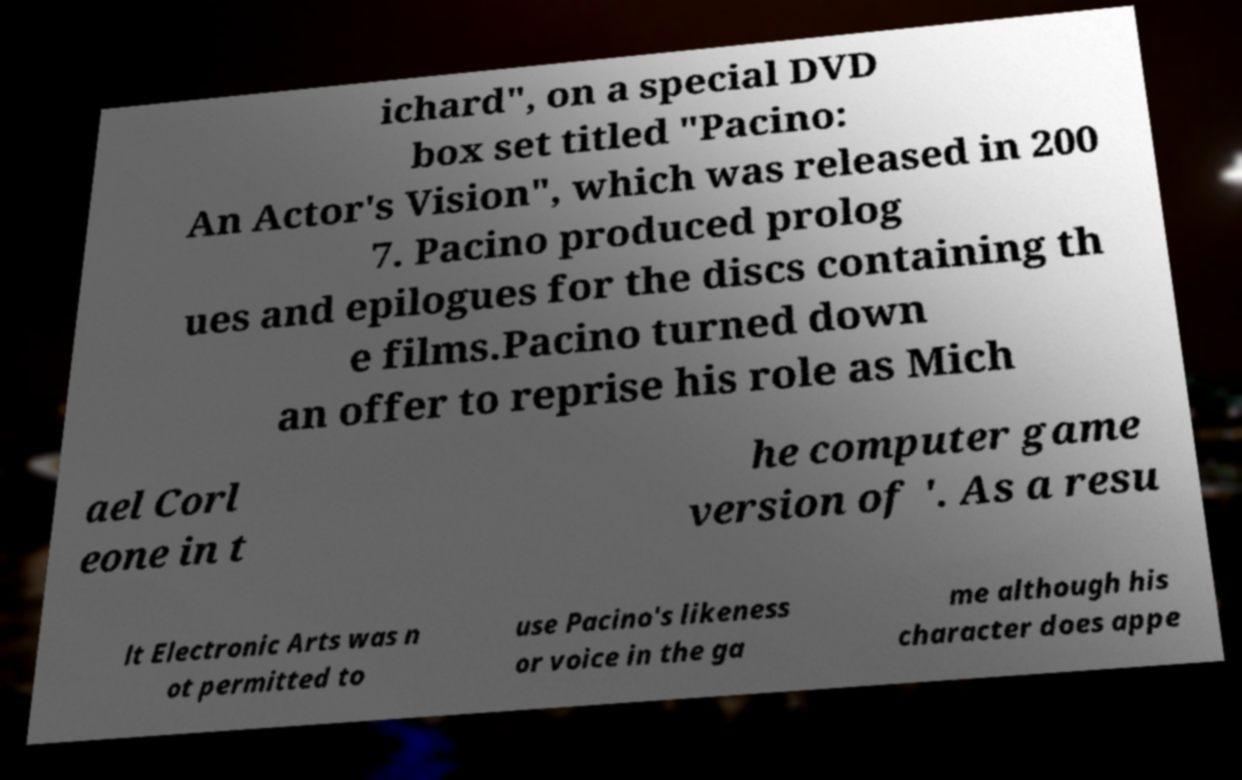Can you read and provide the text displayed in the image?This photo seems to have some interesting text. Can you extract and type it out for me? ichard", on a special DVD box set titled "Pacino: An Actor's Vision", which was released in 200 7. Pacino produced prolog ues and epilogues for the discs containing th e films.Pacino turned down an offer to reprise his role as Mich ael Corl eone in t he computer game version of '. As a resu lt Electronic Arts was n ot permitted to use Pacino's likeness or voice in the ga me although his character does appe 